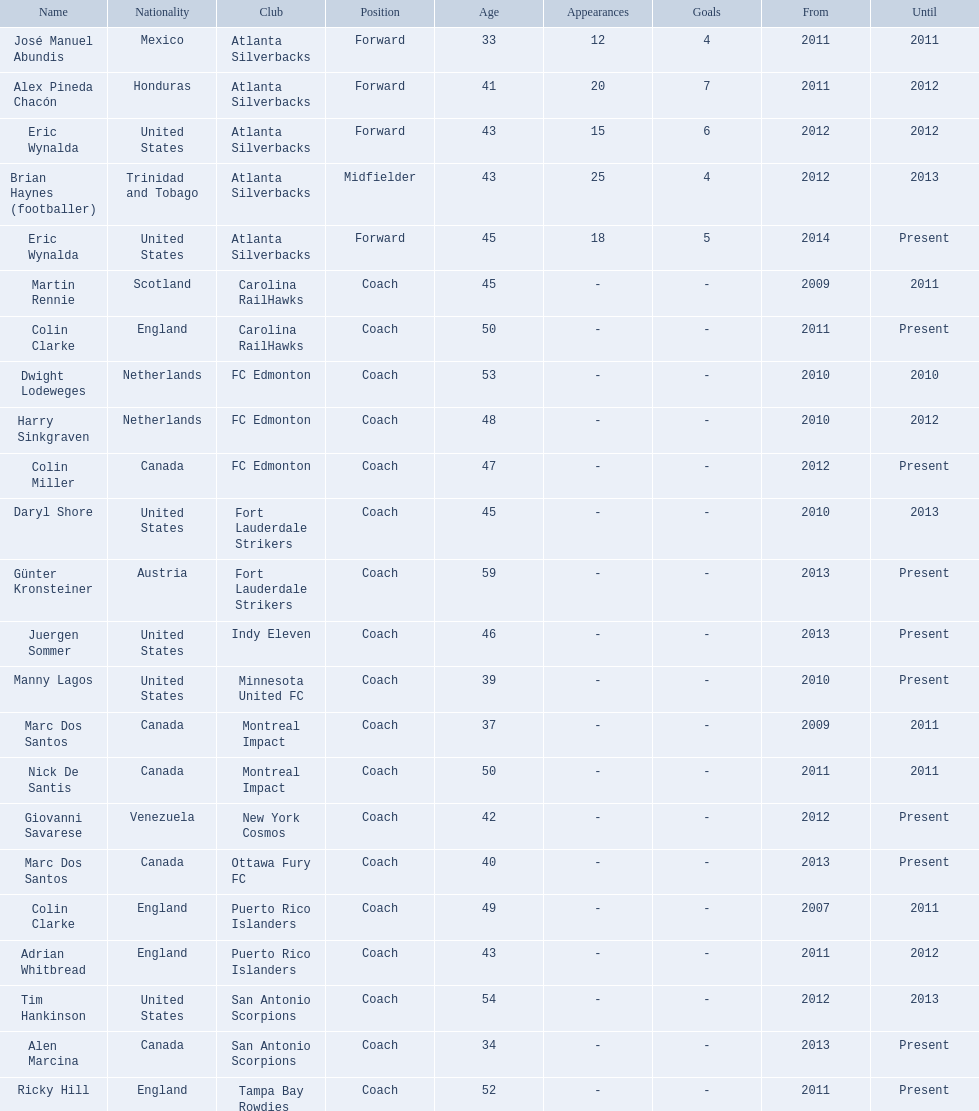What were all the coaches who were coaching in 2010? Martin Rennie, Dwight Lodeweges, Harry Sinkgraven, Daryl Shore, Manny Lagos, Marc Dos Santos, Colin Clarke. Which of the 2010 coaches were not born in north america? Martin Rennie, Dwight Lodeweges, Harry Sinkgraven, Colin Clarke. Which coaches that were coaching in 2010 and were not from north america did not coach for fc edmonton? Martin Rennie, Colin Clarke. What coach did not coach for fc edmonton in 2010 and was not north american nationality had the shortened career as a coach? Martin Rennie. 